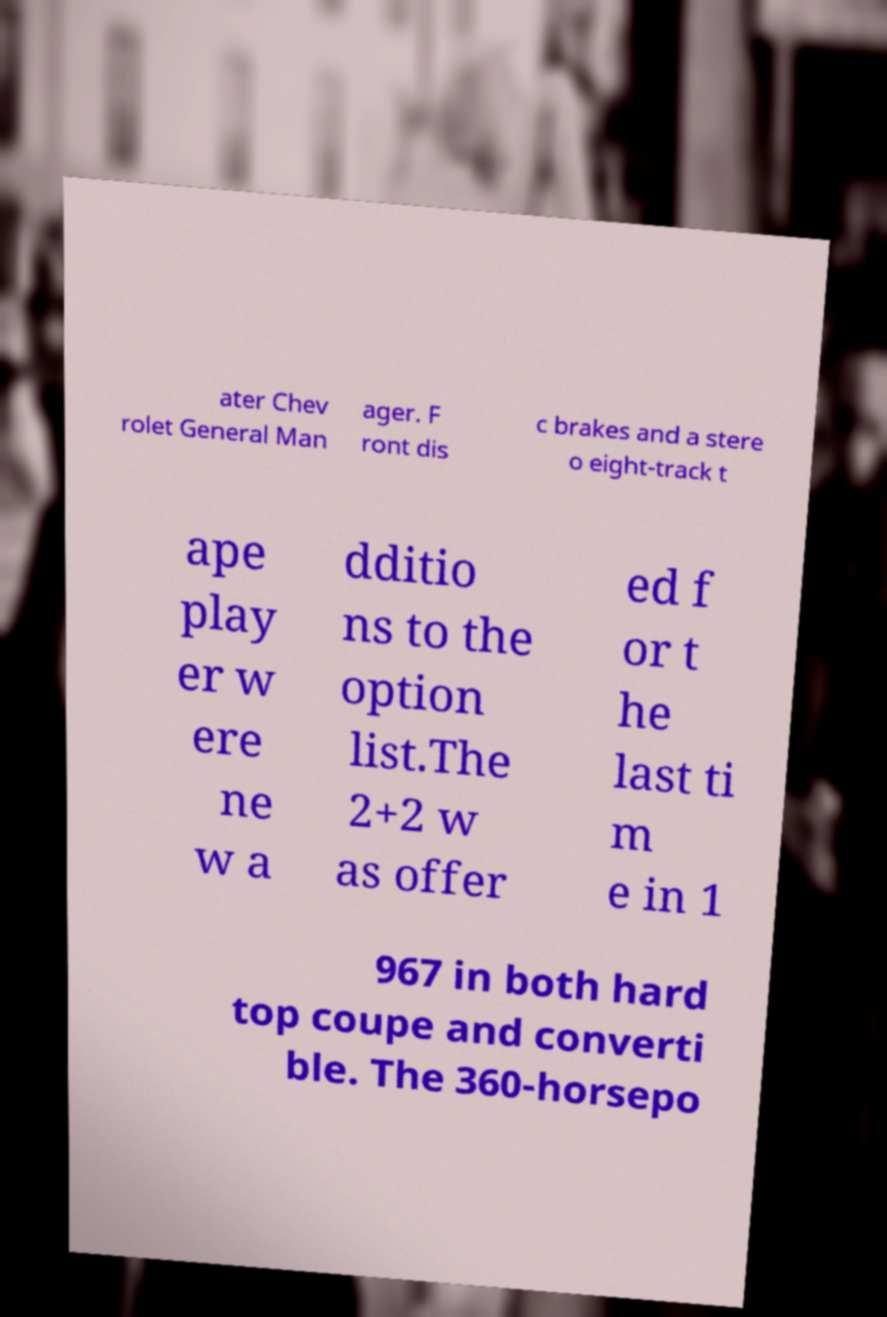Can you read and provide the text displayed in the image?This photo seems to have some interesting text. Can you extract and type it out for me? ater Chev rolet General Man ager. F ront dis c brakes and a stere o eight-track t ape play er w ere ne w a dditio ns to the option list.The 2+2 w as offer ed f or t he last ti m e in 1 967 in both hard top coupe and converti ble. The 360-horsepo 